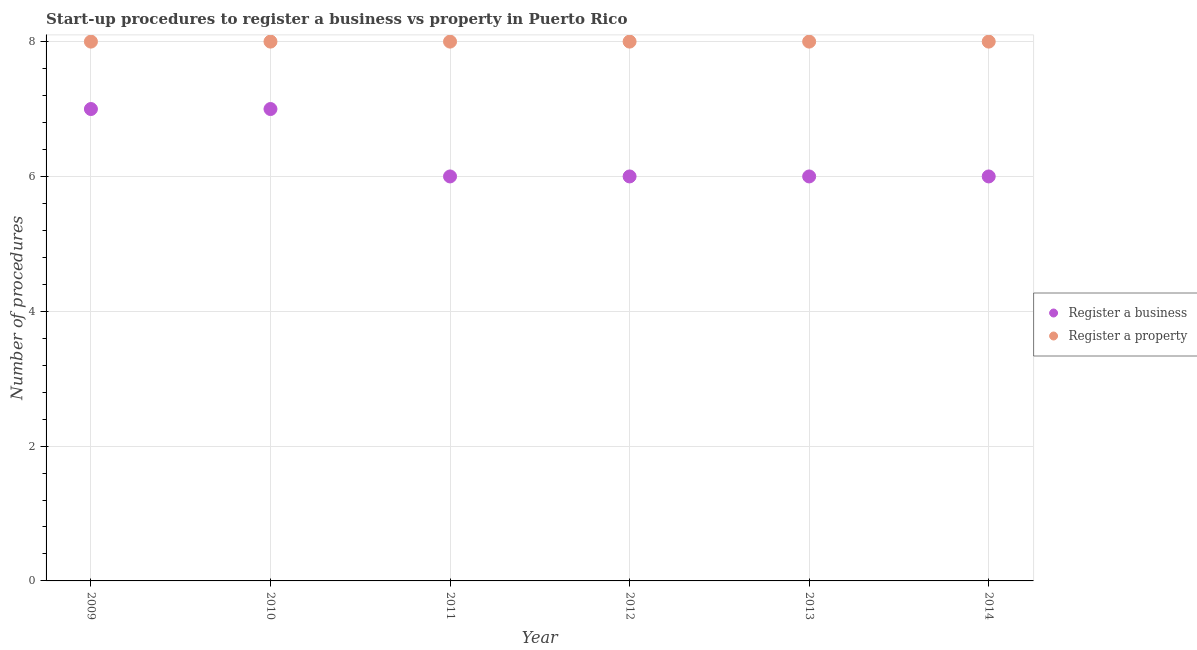How many different coloured dotlines are there?
Make the answer very short. 2. What is the number of procedures to register a property in 2010?
Your response must be concise. 8. Across all years, what is the maximum number of procedures to register a business?
Offer a very short reply. 7. Across all years, what is the minimum number of procedures to register a property?
Keep it short and to the point. 8. What is the total number of procedures to register a property in the graph?
Offer a very short reply. 48. What is the difference between the number of procedures to register a property in 2010 and the number of procedures to register a business in 2013?
Make the answer very short. 2. What is the average number of procedures to register a property per year?
Offer a very short reply. 8. In the year 2010, what is the difference between the number of procedures to register a property and number of procedures to register a business?
Give a very brief answer. 1. In how many years, is the number of procedures to register a business greater than 7.2?
Ensure brevity in your answer.  0. Is the number of procedures to register a property in 2009 less than that in 2013?
Ensure brevity in your answer.  No. What is the difference between the highest and the second highest number of procedures to register a business?
Ensure brevity in your answer.  0. In how many years, is the number of procedures to register a business greater than the average number of procedures to register a business taken over all years?
Offer a very short reply. 2. Is the sum of the number of procedures to register a business in 2009 and 2014 greater than the maximum number of procedures to register a property across all years?
Give a very brief answer. Yes. Does the number of procedures to register a business monotonically increase over the years?
Your answer should be very brief. No. Is the number of procedures to register a business strictly greater than the number of procedures to register a property over the years?
Offer a very short reply. No. How many years are there in the graph?
Make the answer very short. 6. Does the graph contain any zero values?
Your answer should be compact. No. Does the graph contain grids?
Your answer should be compact. Yes. Where does the legend appear in the graph?
Offer a terse response. Center right. What is the title of the graph?
Your response must be concise. Start-up procedures to register a business vs property in Puerto Rico. Does "Working capital" appear as one of the legend labels in the graph?
Your response must be concise. No. What is the label or title of the Y-axis?
Your response must be concise. Number of procedures. What is the Number of procedures of Register a business in 2009?
Your response must be concise. 7. What is the Number of procedures of Register a business in 2010?
Provide a succinct answer. 7. What is the Number of procedures in Register a property in 2010?
Your response must be concise. 8. What is the Number of procedures in Register a property in 2011?
Make the answer very short. 8. What is the Number of procedures in Register a business in 2012?
Provide a succinct answer. 6. What is the Number of procedures of Register a business in 2013?
Offer a very short reply. 6. What is the Number of procedures in Register a property in 2013?
Provide a succinct answer. 8. What is the Number of procedures of Register a business in 2014?
Make the answer very short. 6. Across all years, what is the maximum Number of procedures in Register a property?
Ensure brevity in your answer.  8. Across all years, what is the minimum Number of procedures of Register a property?
Your response must be concise. 8. What is the total Number of procedures in Register a business in the graph?
Your response must be concise. 38. What is the difference between the Number of procedures of Register a business in 2009 and that in 2010?
Your response must be concise. 0. What is the difference between the Number of procedures of Register a property in 2009 and that in 2011?
Your response must be concise. 0. What is the difference between the Number of procedures of Register a property in 2009 and that in 2013?
Give a very brief answer. 0. What is the difference between the Number of procedures of Register a business in 2009 and that in 2014?
Your response must be concise. 1. What is the difference between the Number of procedures of Register a property in 2009 and that in 2014?
Give a very brief answer. 0. What is the difference between the Number of procedures of Register a business in 2010 and that in 2011?
Your answer should be compact. 1. What is the difference between the Number of procedures in Register a property in 2010 and that in 2011?
Make the answer very short. 0. What is the difference between the Number of procedures in Register a business in 2010 and that in 2014?
Your answer should be very brief. 1. What is the difference between the Number of procedures of Register a business in 2011 and that in 2012?
Your answer should be very brief. 0. What is the difference between the Number of procedures in Register a business in 2011 and that in 2014?
Your response must be concise. 0. What is the difference between the Number of procedures in Register a property in 2011 and that in 2014?
Ensure brevity in your answer.  0. What is the difference between the Number of procedures of Register a property in 2012 and that in 2013?
Your answer should be very brief. 0. What is the difference between the Number of procedures in Register a business in 2012 and that in 2014?
Provide a short and direct response. 0. What is the difference between the Number of procedures in Register a property in 2013 and that in 2014?
Your response must be concise. 0. What is the difference between the Number of procedures in Register a business in 2009 and the Number of procedures in Register a property in 2010?
Offer a terse response. -1. What is the difference between the Number of procedures of Register a business in 2009 and the Number of procedures of Register a property in 2013?
Give a very brief answer. -1. What is the difference between the Number of procedures of Register a business in 2010 and the Number of procedures of Register a property in 2012?
Keep it short and to the point. -1. What is the difference between the Number of procedures in Register a business in 2010 and the Number of procedures in Register a property in 2013?
Your answer should be compact. -1. What is the difference between the Number of procedures in Register a business in 2010 and the Number of procedures in Register a property in 2014?
Offer a terse response. -1. What is the difference between the Number of procedures in Register a business in 2011 and the Number of procedures in Register a property in 2012?
Ensure brevity in your answer.  -2. What is the difference between the Number of procedures of Register a business in 2011 and the Number of procedures of Register a property in 2013?
Keep it short and to the point. -2. What is the difference between the Number of procedures in Register a business in 2011 and the Number of procedures in Register a property in 2014?
Provide a succinct answer. -2. What is the difference between the Number of procedures of Register a business in 2012 and the Number of procedures of Register a property in 2014?
Your response must be concise. -2. What is the average Number of procedures in Register a business per year?
Your response must be concise. 6.33. What is the average Number of procedures in Register a property per year?
Ensure brevity in your answer.  8. In the year 2010, what is the difference between the Number of procedures in Register a business and Number of procedures in Register a property?
Your response must be concise. -1. In the year 2012, what is the difference between the Number of procedures of Register a business and Number of procedures of Register a property?
Your answer should be compact. -2. In the year 2014, what is the difference between the Number of procedures in Register a business and Number of procedures in Register a property?
Your answer should be very brief. -2. What is the ratio of the Number of procedures in Register a business in 2009 to that in 2010?
Offer a terse response. 1. What is the ratio of the Number of procedures of Register a property in 2009 to that in 2010?
Keep it short and to the point. 1. What is the ratio of the Number of procedures of Register a business in 2009 to that in 2011?
Make the answer very short. 1.17. What is the ratio of the Number of procedures in Register a property in 2009 to that in 2012?
Your answer should be compact. 1. What is the ratio of the Number of procedures of Register a business in 2009 to that in 2013?
Offer a terse response. 1.17. What is the ratio of the Number of procedures in Register a property in 2009 to that in 2014?
Offer a terse response. 1. What is the ratio of the Number of procedures of Register a business in 2010 to that in 2011?
Give a very brief answer. 1.17. What is the ratio of the Number of procedures in Register a property in 2010 to that in 2012?
Offer a very short reply. 1. What is the ratio of the Number of procedures in Register a business in 2010 to that in 2014?
Make the answer very short. 1.17. What is the ratio of the Number of procedures of Register a property in 2010 to that in 2014?
Offer a very short reply. 1. What is the ratio of the Number of procedures of Register a property in 2011 to that in 2012?
Your answer should be compact. 1. What is the ratio of the Number of procedures of Register a business in 2011 to that in 2013?
Your answer should be compact. 1. What is the ratio of the Number of procedures of Register a property in 2011 to that in 2013?
Ensure brevity in your answer.  1. What is the ratio of the Number of procedures of Register a business in 2011 to that in 2014?
Keep it short and to the point. 1. What is the ratio of the Number of procedures of Register a business in 2012 to that in 2013?
Keep it short and to the point. 1. What is the ratio of the Number of procedures of Register a business in 2012 to that in 2014?
Your response must be concise. 1. What is the ratio of the Number of procedures in Register a property in 2012 to that in 2014?
Offer a terse response. 1. What is the ratio of the Number of procedures of Register a business in 2013 to that in 2014?
Your answer should be compact. 1. What is the difference between the highest and the second highest Number of procedures of Register a business?
Keep it short and to the point. 0. What is the difference between the highest and the second highest Number of procedures of Register a property?
Your answer should be very brief. 0. 